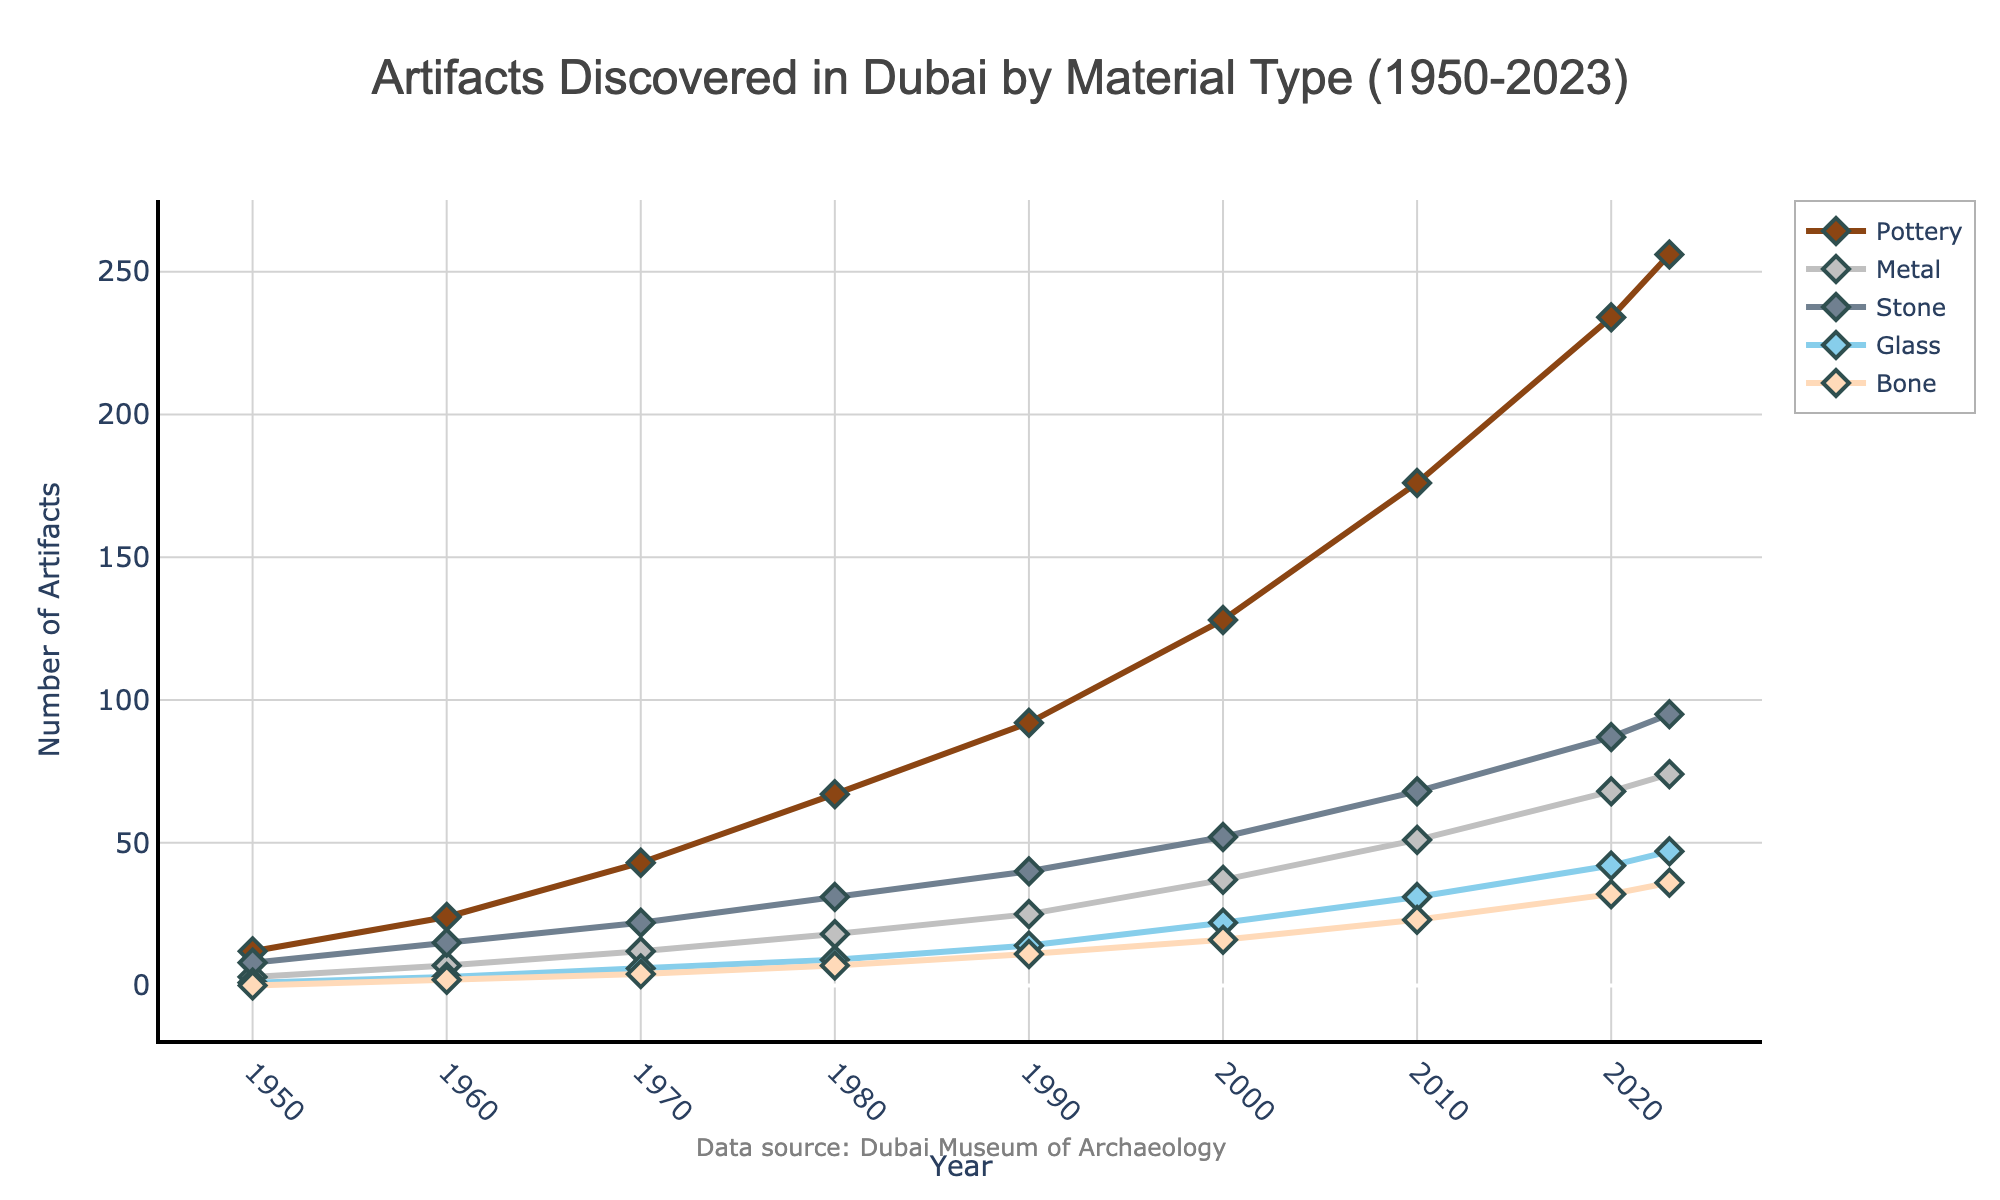What is the total increase in the number of pottery artifacts discovered from 1950 to 2023? Subtract the number of pottery artifacts discovered in 1950 (12) from the number discovered in 2023 (256). The calculation is 256 - 12 = 244.
Answer: 244 Which material type saw the largest increase in the number of artifacts discovered from 1950 to 2023? Calculate the increase for each material type by subtracting the 1950 value from the 2023 value:
- Pottery: 256 - 12 = 244
- Metal: 74 - 3 = 71
- Stone: 95 - 8 = 87
- Glass: 47 - 1 = 46
- Bone: 36 - 0 = 36
Pottery has the largest increase.
Answer: Pottery What was the number of glass artifacts discovered in 1990 compared to 2010? Find the number of glass artifacts in both 1990 and 2010 from the figure:
- 1990: 14
- 2010: 31
Then compare: 31 > 14. So, the number of glass artifacts discovered in 2010 was greater than in 1990.
Answer: Greater in 2010 Which material had the least number of artifacts discovered in 2000? Compare the values for all materials in 2000:
- Pottery: 128
- Metal: 37
- Stone: 52
- Glass: 22
- Bone: 16
Bone has the least number of artifacts.
Answer: Bone How did the number of stone artifacts discovered change from 1980 to 2020? Find the number of stone artifacts discovered in 1980 (31) and in 2020 (87). The change is calculated as 87 - 31 = 56.
Answer: Increased by 56 Is the number of metal artifacts discovered between 2000 and 2010 greater than or less than between 1990 and 2000? Calculate the changes for both periods:
- 2000 to 2010: 51 - 37 = 14
- 1990 to 2000: 37 - 25 = 12
The change from 2000 to 2010 is 14, which is greater than the change from 1990 to 2000, which is 12.
Answer: Greater Which year saw the highest number of artifacts discovered in total across all material types? Sum up the numbers for each material type for each year and find the year with the highest total:
1950: 12 + 3 + 8 + 1 + 0 = 24
1960: 24 + 7 + 15 + 3 + 2 = 51
1970: 43 + 12 + 22 + 6 + 4 = 87
1980: 67 + 18 + 31 + 9 + 7 = 132
1990: 92 + 25 + 40 + 14 + 11 = 182
2000: 128 + 37 + 52 + 22 + 16 = 255
2010: 176 + 51 + 68 + 31 + 23 = 349
2020: 234 + 68 + 87 + 42 + 32 = 463
2023: 256 + 74 + 95 + 47 + 36 = 508
The highest total is in 2023 with 508 artifacts.
Answer: 2023 How many bone artifacts were discovered in 2023 compared to 1960? Find the number of bone artifacts in both years from the figure:
- 1960: 2
- 2023: 36
Compare the two values: 36 > 2. So, the number of bone artifacts discovered in 2023 was greater than in 1960.
Answer: Greater in 2023 